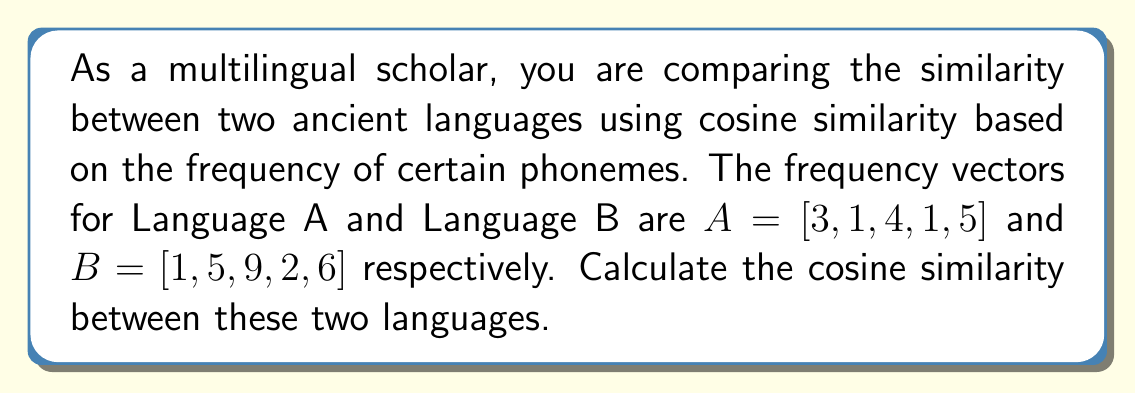Help me with this question. To calculate the cosine similarity between two vectors, we use the formula:

$$\text{Cosine Similarity} = \frac{A \cdot B}{\|A\| \|B\|}$$

Where $A \cdot B$ is the dot product of the vectors, and $\|A\|$ and $\|B\|$ are the magnitudes of vectors A and B respectively.

Step 1: Calculate the dot product $A \cdot B$
$A \cdot B = (3)(1) + (1)(5) + (4)(9) + (1)(2) + (5)(6) = 3 + 5 + 36 + 2 + 30 = 76$

Step 2: Calculate $\|A\|$
$\|A\| = \sqrt{3^2 + 1^2 + 4^2 + 1^2 + 5^2} = \sqrt{9 + 1 + 16 + 1 + 25} = \sqrt{52} \approx 7.21110$

Step 3: Calculate $\|B\|$
$\|B\| = \sqrt{1^2 + 5^2 + 9^2 + 2^2 + 6^2} = \sqrt{1 + 25 + 81 + 4 + 36} = \sqrt{147} \approx 12.12436$

Step 4: Calculate the cosine similarity
$$\text{Cosine Similarity} = \frac{76}{7.21110 \times 12.12436} \approx 0.87039$$
Answer: $0.87039$ 